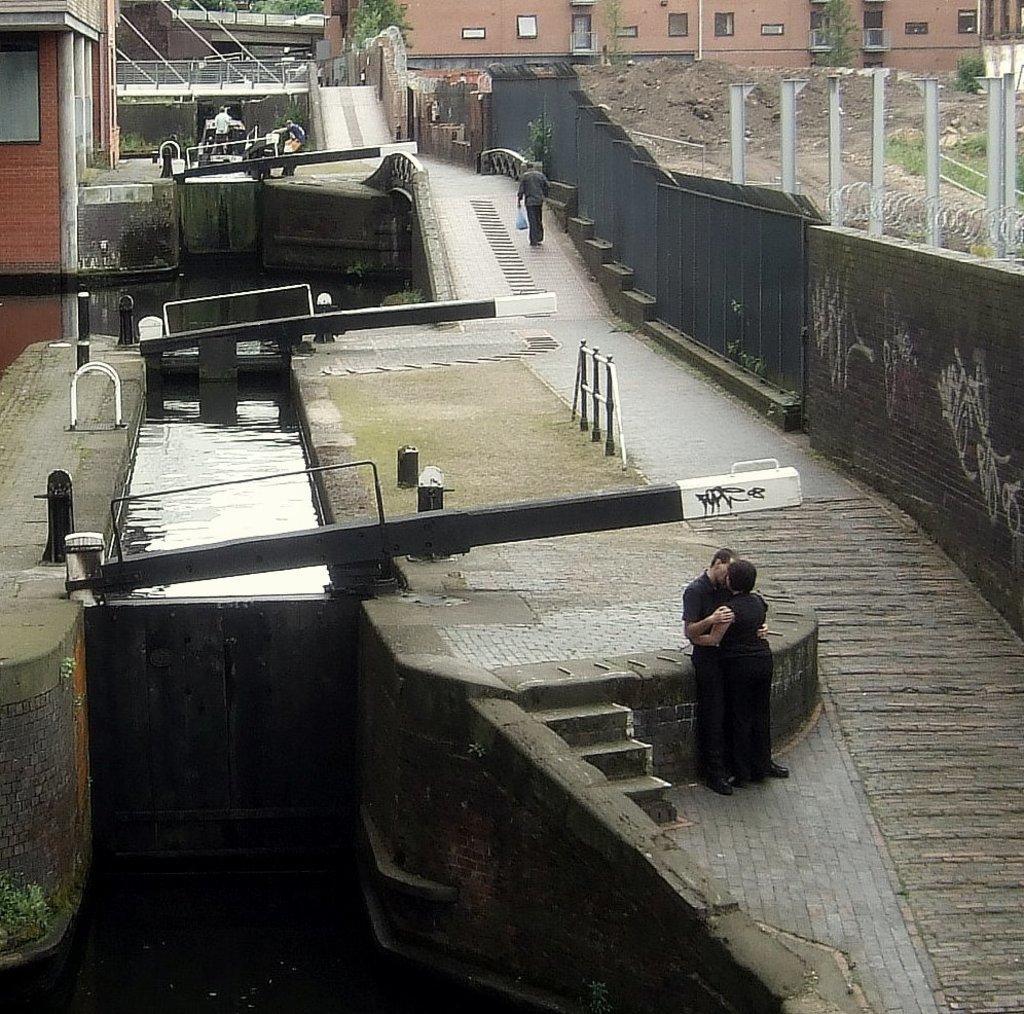In one or two sentences, can you explain what this image depicts? In the image I can see two people who are standing and around there are some other houses, poles, grills, water and some other things. 